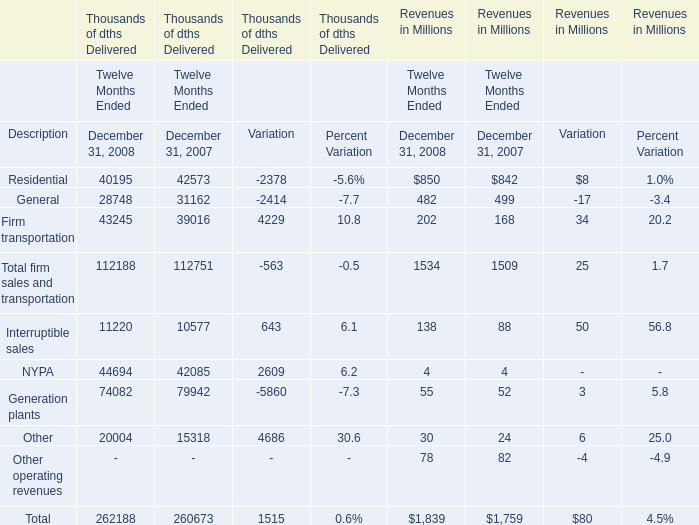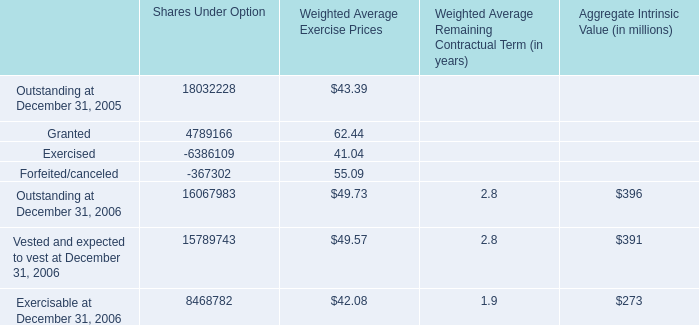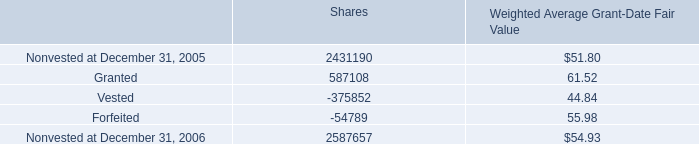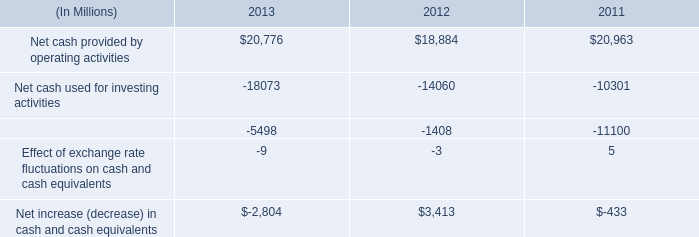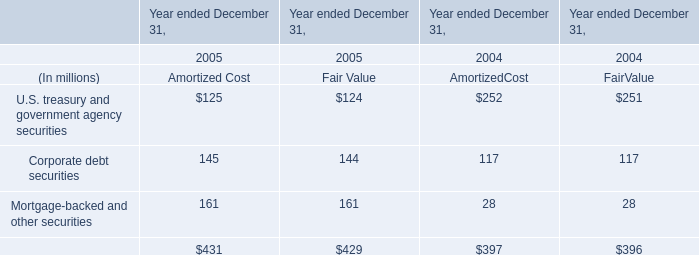in 2013 what was the approximate percentage increase in net cash provided by operating activities 
Computations: (19 / 18884)
Answer: 0.00101. 